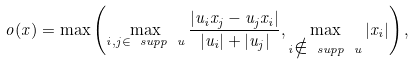Convert formula to latex. <formula><loc_0><loc_0><loc_500><loc_500>o ( x ) = \max \left ( \max _ { i , j \in \ s u p p \ u } \frac { | u _ { i } x _ { j } - u _ { j } x _ { i } | } { | u _ { i } | + | u _ { j } | } , \max _ { i \notin \ s u p p \ u } | x _ { i } | \right ) ,</formula> 